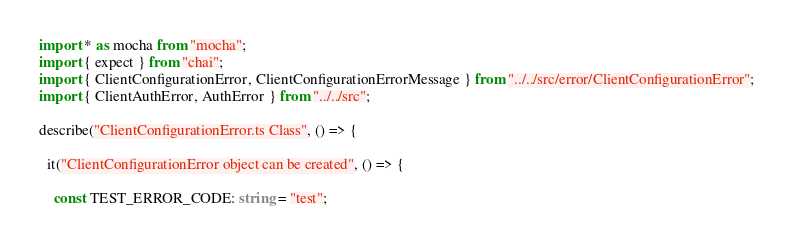<code> <loc_0><loc_0><loc_500><loc_500><_TypeScript_>import * as mocha from "mocha";
import { expect } from "chai";
import { ClientConfigurationError, ClientConfigurationErrorMessage } from "../../src/error/ClientConfigurationError";
import { ClientAuthError, AuthError } from "../../src";

describe("ClientConfigurationError.ts Class", () => {

  it("ClientConfigurationError object can be created", () => {

    const TEST_ERROR_CODE: string = "test";</code> 